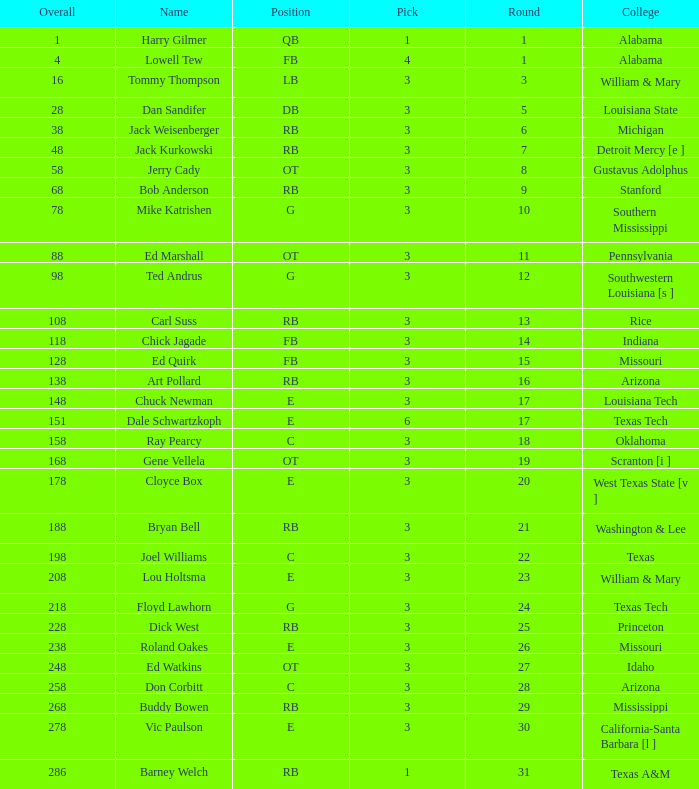How much Overall has a Name of bob anderson? 1.0. 